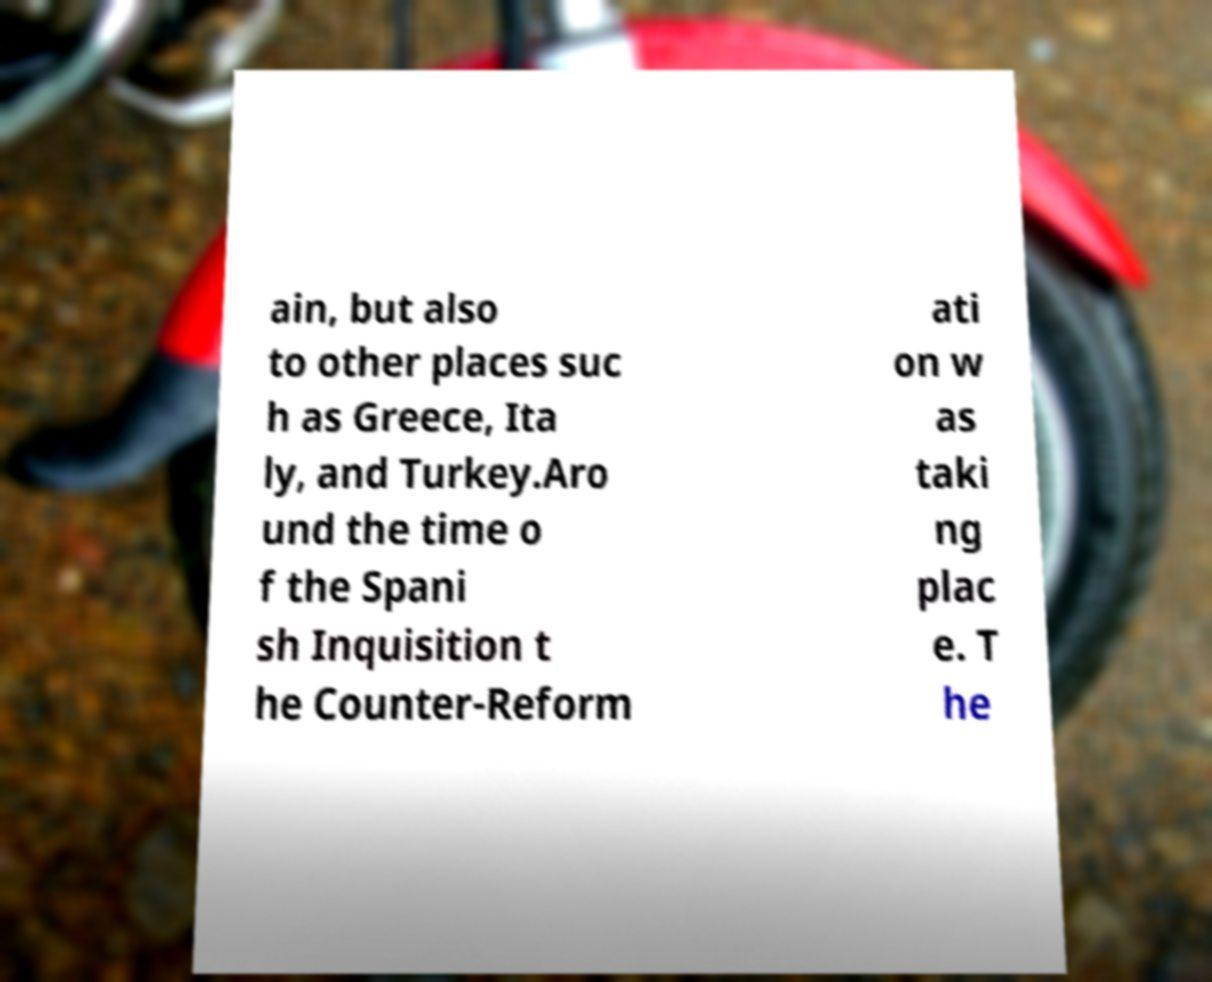I need the written content from this picture converted into text. Can you do that? ain, but also to other places suc h as Greece, Ita ly, and Turkey.Aro und the time o f the Spani sh Inquisition t he Counter-Reform ati on w as taki ng plac e. T he 